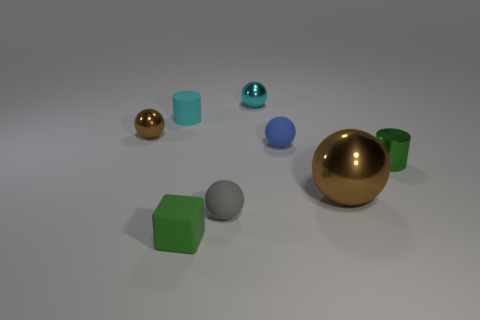Subtract all blue matte spheres. How many spheres are left? 4 Subtract all blue spheres. How many spheres are left? 4 Subtract all blue spheres. Subtract all yellow blocks. How many spheres are left? 4 Add 2 tiny shiny things. How many objects exist? 10 Subtract all cylinders. How many objects are left? 6 Add 3 small metallic objects. How many small metallic objects exist? 6 Subtract 0 red cylinders. How many objects are left? 8 Subtract all tiny brown balls. Subtract all green things. How many objects are left? 5 Add 3 brown things. How many brown things are left? 5 